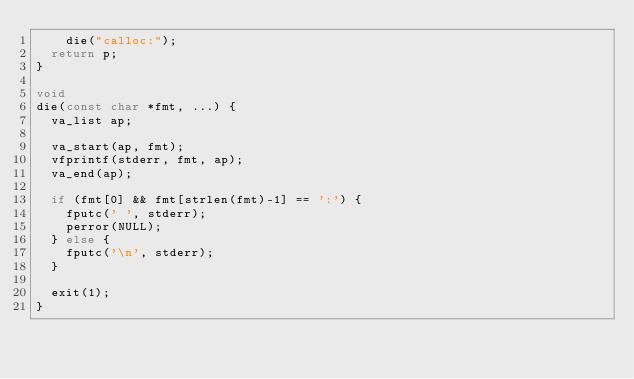<code> <loc_0><loc_0><loc_500><loc_500><_C_>    die("calloc:");
  return p;
}

void
die(const char *fmt, ...) {
  va_list ap;

  va_start(ap, fmt);
  vfprintf(stderr, fmt, ap);
  va_end(ap);

  if (fmt[0] && fmt[strlen(fmt)-1] == ':') {
    fputc(' ', stderr);
    perror(NULL);
  } else {
    fputc('\n', stderr);
  }

  exit(1);
}
</code> 